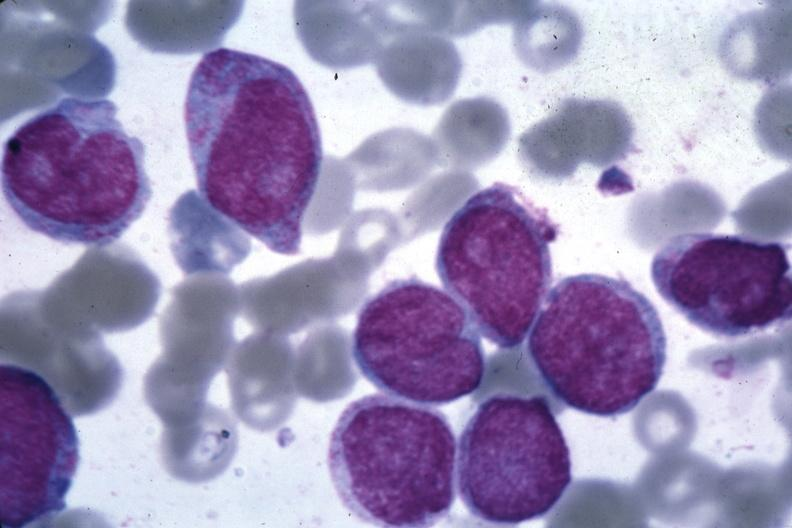s malignant histiocytosis present?
Answer the question using a single word or phrase. No 